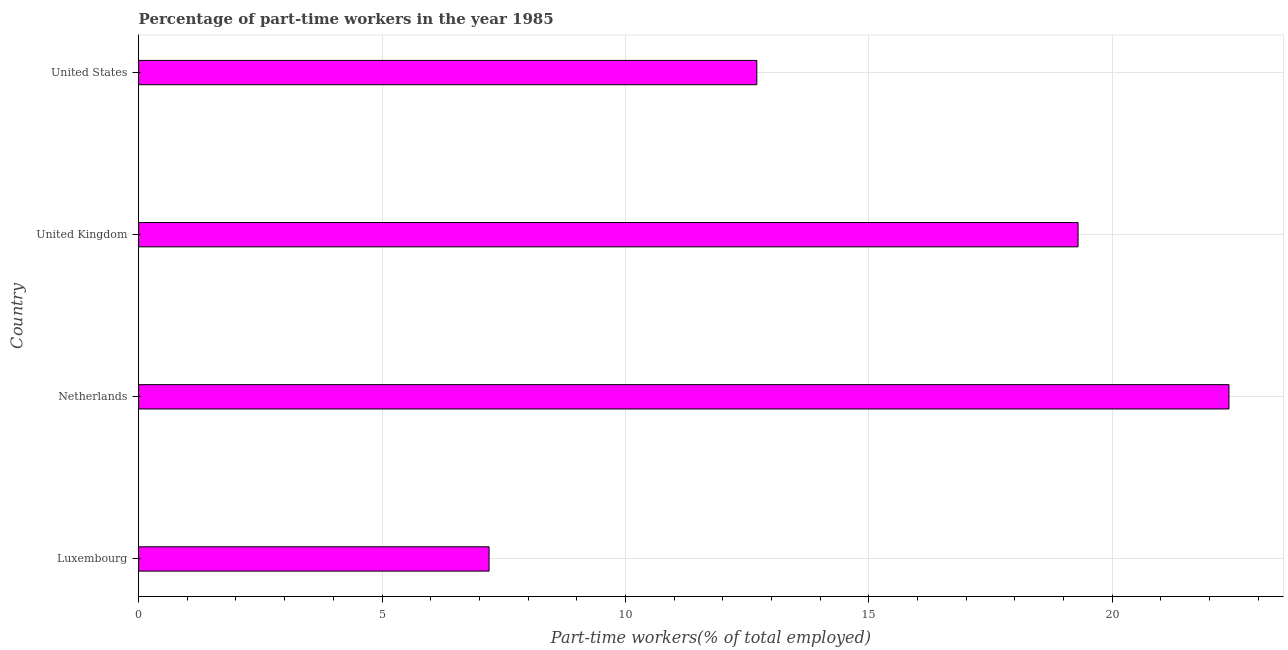Does the graph contain grids?
Provide a succinct answer. Yes. What is the title of the graph?
Your answer should be compact. Percentage of part-time workers in the year 1985. What is the label or title of the X-axis?
Make the answer very short. Part-time workers(% of total employed). What is the label or title of the Y-axis?
Give a very brief answer. Country. What is the percentage of part-time workers in United Kingdom?
Offer a very short reply. 19.3. Across all countries, what is the maximum percentage of part-time workers?
Give a very brief answer. 22.4. Across all countries, what is the minimum percentage of part-time workers?
Offer a terse response. 7.2. In which country was the percentage of part-time workers minimum?
Provide a short and direct response. Luxembourg. What is the sum of the percentage of part-time workers?
Ensure brevity in your answer.  61.6. What is the median percentage of part-time workers?
Your response must be concise. 16. In how many countries, is the percentage of part-time workers greater than 1 %?
Make the answer very short. 4. What is the ratio of the percentage of part-time workers in Netherlands to that in United States?
Give a very brief answer. 1.76. Is the percentage of part-time workers in Netherlands less than that in United Kingdom?
Provide a succinct answer. No. What is the difference between the highest and the second highest percentage of part-time workers?
Offer a very short reply. 3.1. Is the sum of the percentage of part-time workers in Luxembourg and United States greater than the maximum percentage of part-time workers across all countries?
Provide a succinct answer. No. What is the difference between two consecutive major ticks on the X-axis?
Provide a short and direct response. 5. What is the Part-time workers(% of total employed) in Luxembourg?
Make the answer very short. 7.2. What is the Part-time workers(% of total employed) in Netherlands?
Make the answer very short. 22.4. What is the Part-time workers(% of total employed) of United Kingdom?
Provide a short and direct response. 19.3. What is the Part-time workers(% of total employed) in United States?
Your answer should be very brief. 12.7. What is the difference between the Part-time workers(% of total employed) in Luxembourg and Netherlands?
Your answer should be very brief. -15.2. What is the difference between the Part-time workers(% of total employed) in Netherlands and United Kingdom?
Keep it short and to the point. 3.1. What is the difference between the Part-time workers(% of total employed) in Netherlands and United States?
Make the answer very short. 9.7. What is the ratio of the Part-time workers(% of total employed) in Luxembourg to that in Netherlands?
Keep it short and to the point. 0.32. What is the ratio of the Part-time workers(% of total employed) in Luxembourg to that in United Kingdom?
Provide a succinct answer. 0.37. What is the ratio of the Part-time workers(% of total employed) in Luxembourg to that in United States?
Ensure brevity in your answer.  0.57. What is the ratio of the Part-time workers(% of total employed) in Netherlands to that in United Kingdom?
Your answer should be very brief. 1.16. What is the ratio of the Part-time workers(% of total employed) in Netherlands to that in United States?
Your response must be concise. 1.76. What is the ratio of the Part-time workers(% of total employed) in United Kingdom to that in United States?
Keep it short and to the point. 1.52. 